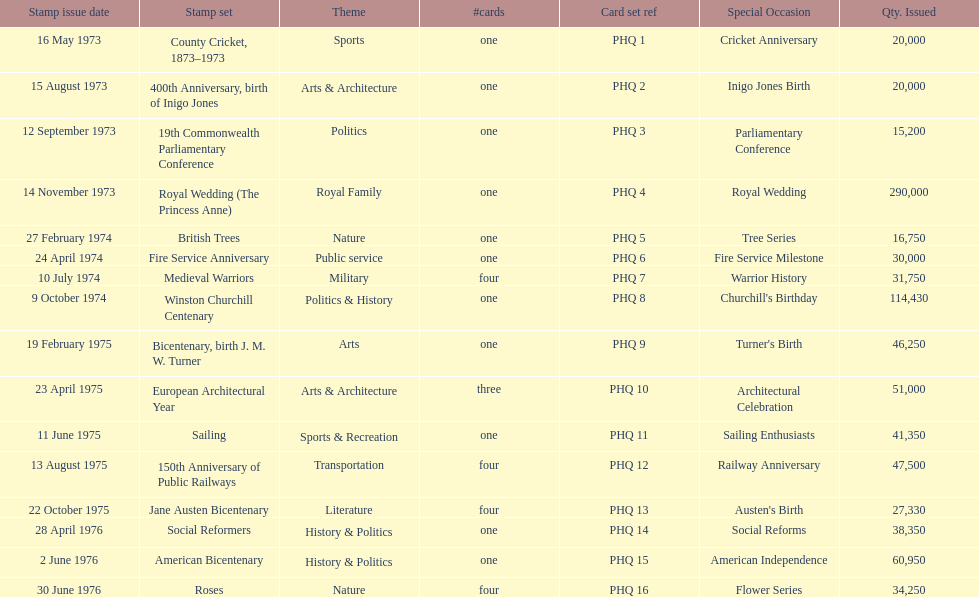Which year had the most stamps issued? 1973. 